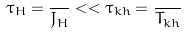<formula> <loc_0><loc_0><loc_500><loc_500>\tau _ { H } = \frac { } { J _ { H } } < < \tau _ { k h } = \frac { } { T _ { k h } }</formula> 